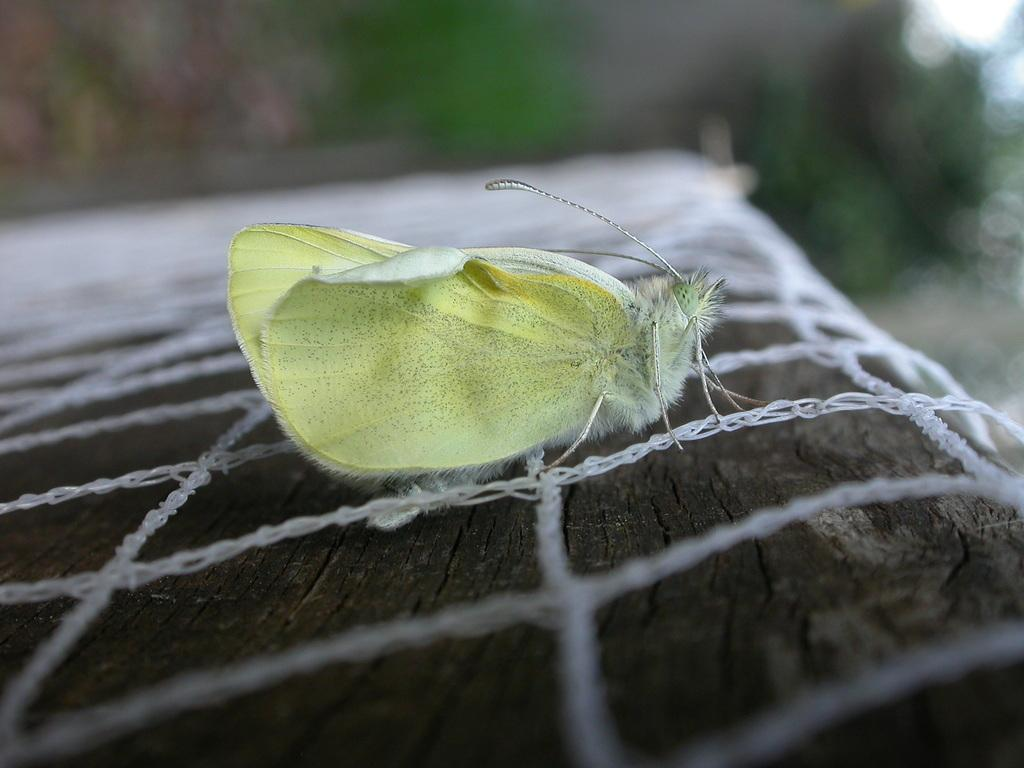What is the main subject of the image? There is a butterfly in the image. Where is the butterfly located? The butterfly is on a net-like object. Can you describe the background of the image? The background of the image is blurred. What type of list can be seen in the image? There is no list present in the image; it features a butterfly on a net-like object with a blurred background. 